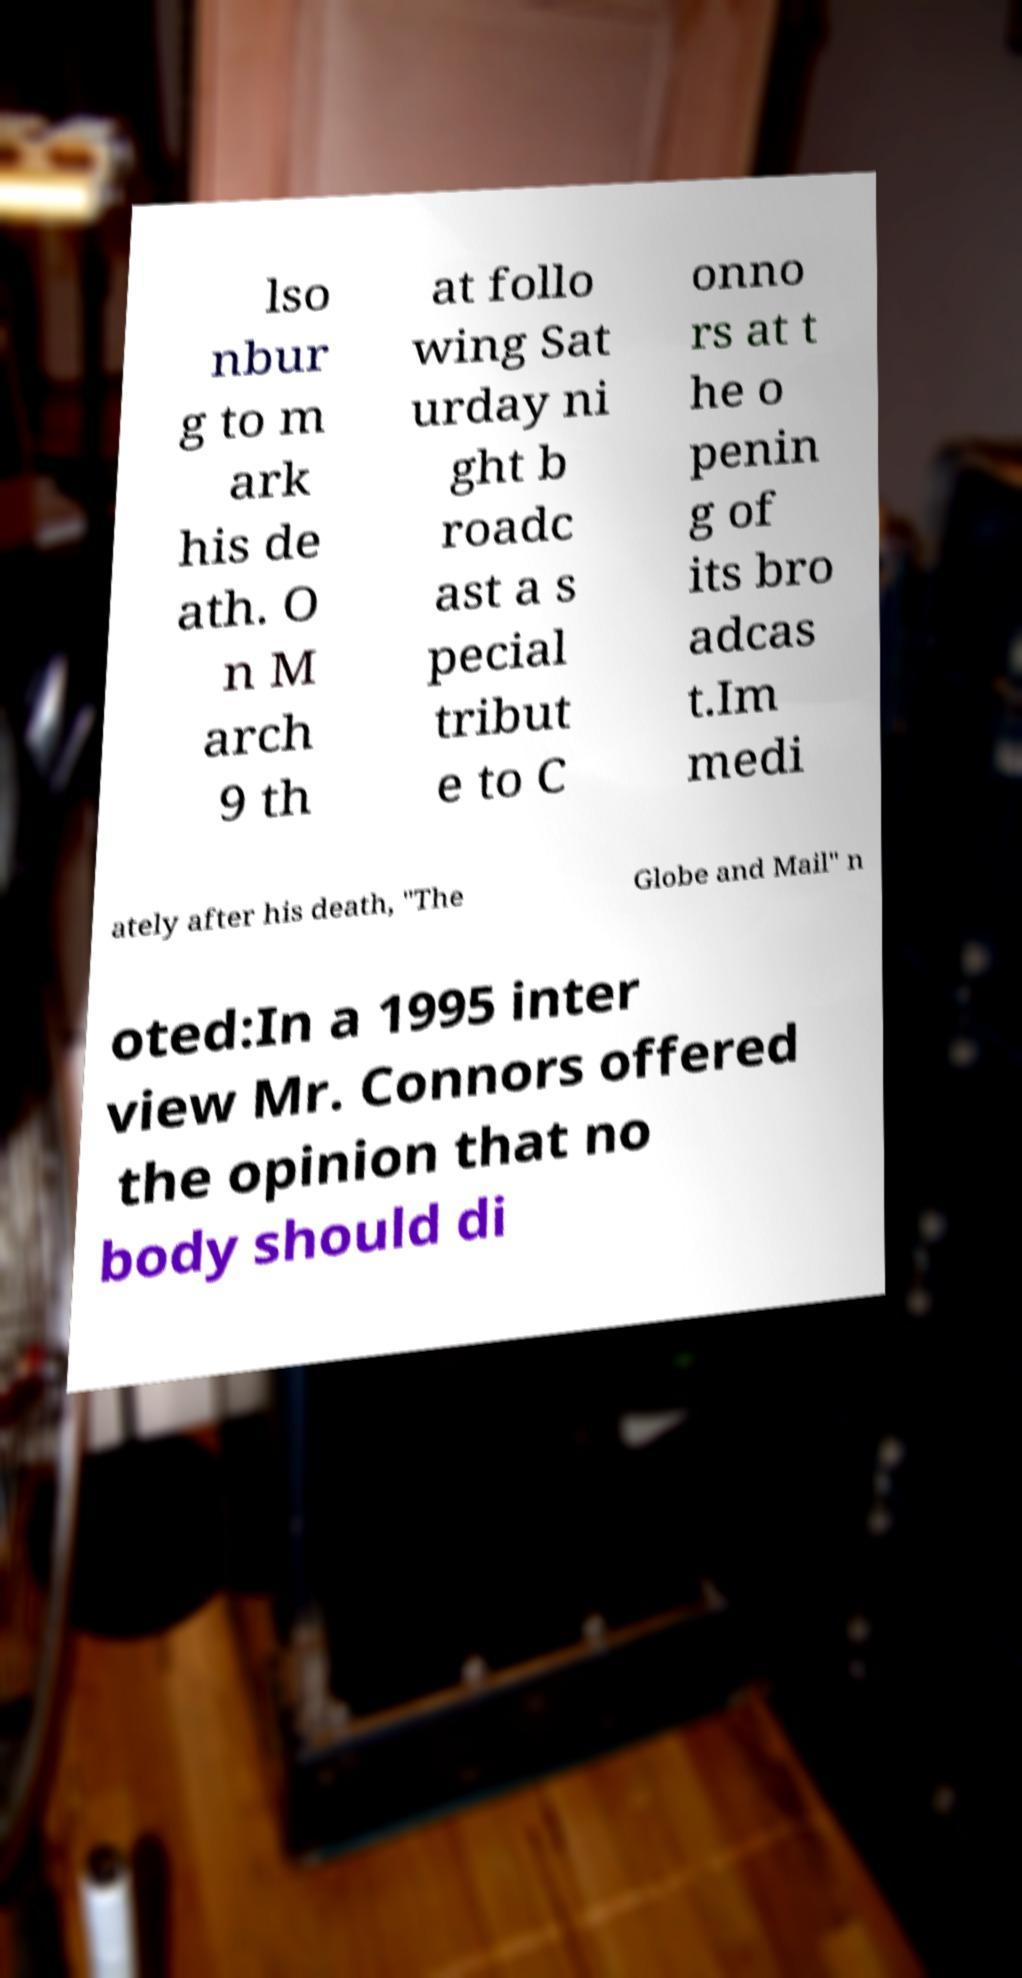Could you extract and type out the text from this image? lso nbur g to m ark his de ath. O n M arch 9 th at follo wing Sat urday ni ght b roadc ast a s pecial tribut e to C onno rs at t he o penin g of its bro adcas t.Im medi ately after his death, "The Globe and Mail" n oted:In a 1995 inter view Mr. Connors offered the opinion that no body should di 